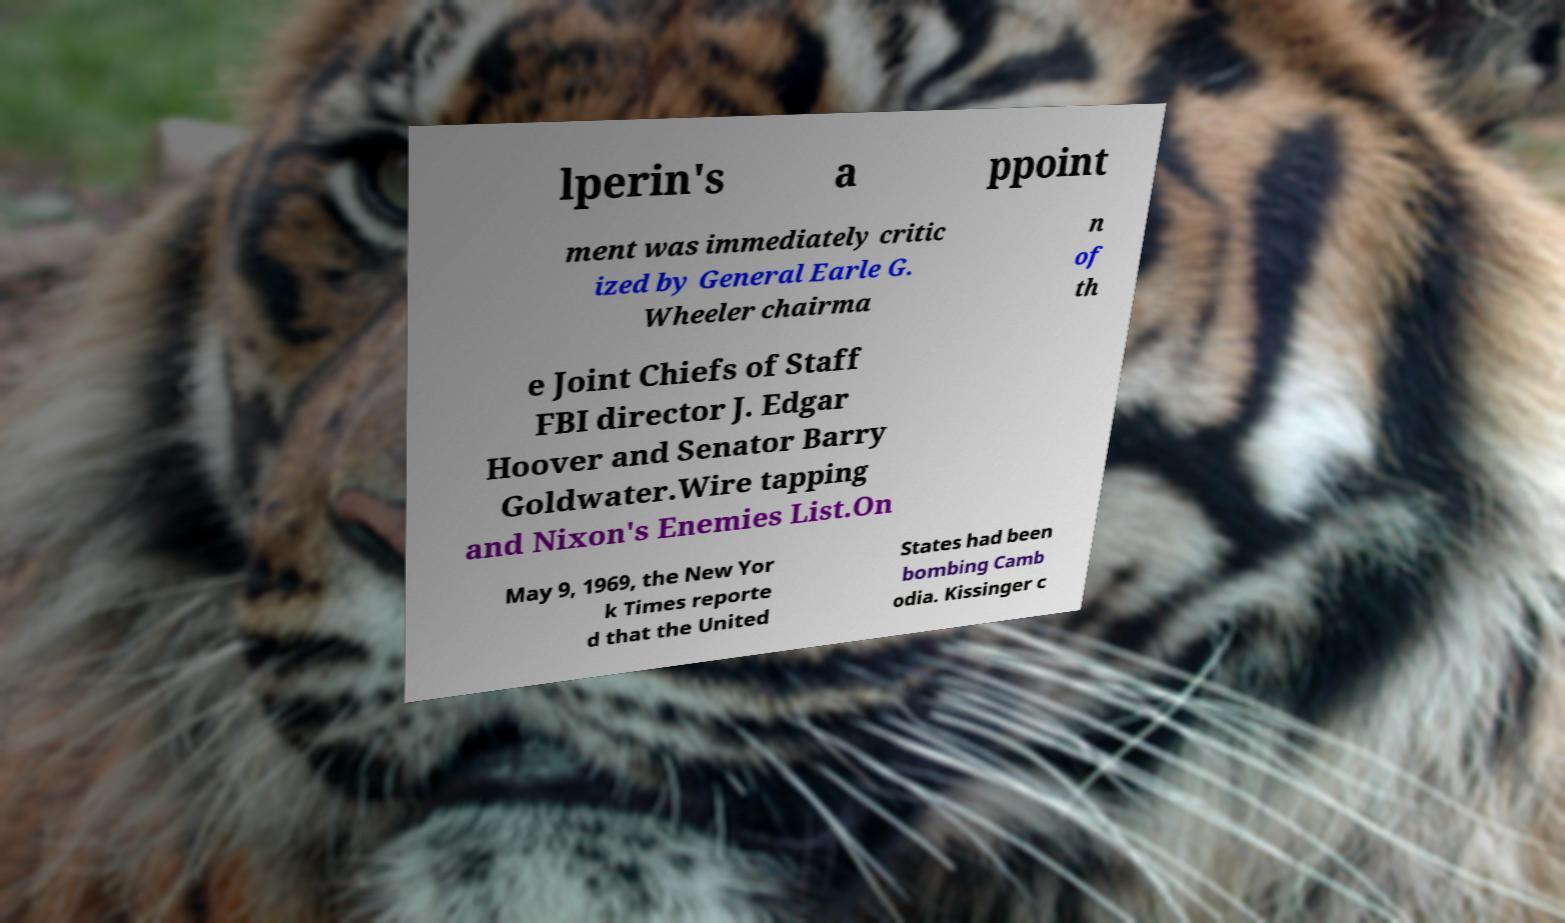Could you assist in decoding the text presented in this image and type it out clearly? lperin's a ppoint ment was immediately critic ized by General Earle G. Wheeler chairma n of th e Joint Chiefs of Staff FBI director J. Edgar Hoover and Senator Barry Goldwater.Wire tapping and Nixon's Enemies List.On May 9, 1969, the New Yor k Times reporte d that the United States had been bombing Camb odia. Kissinger c 